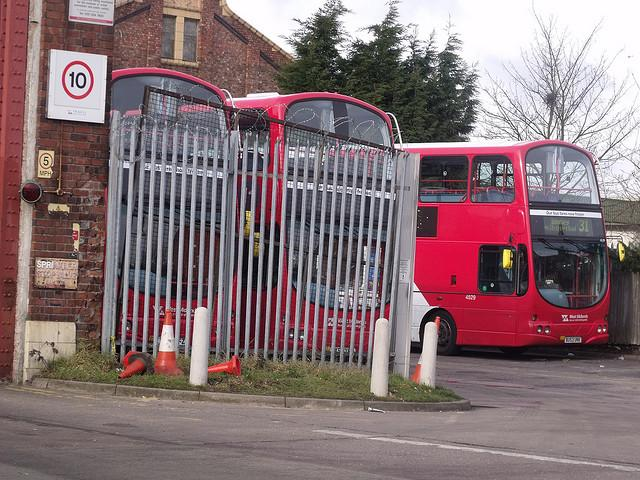Which side of the street do the busses seen here travel when driving forward? Please explain your reasoning. left. This is in london and they drive on that side 